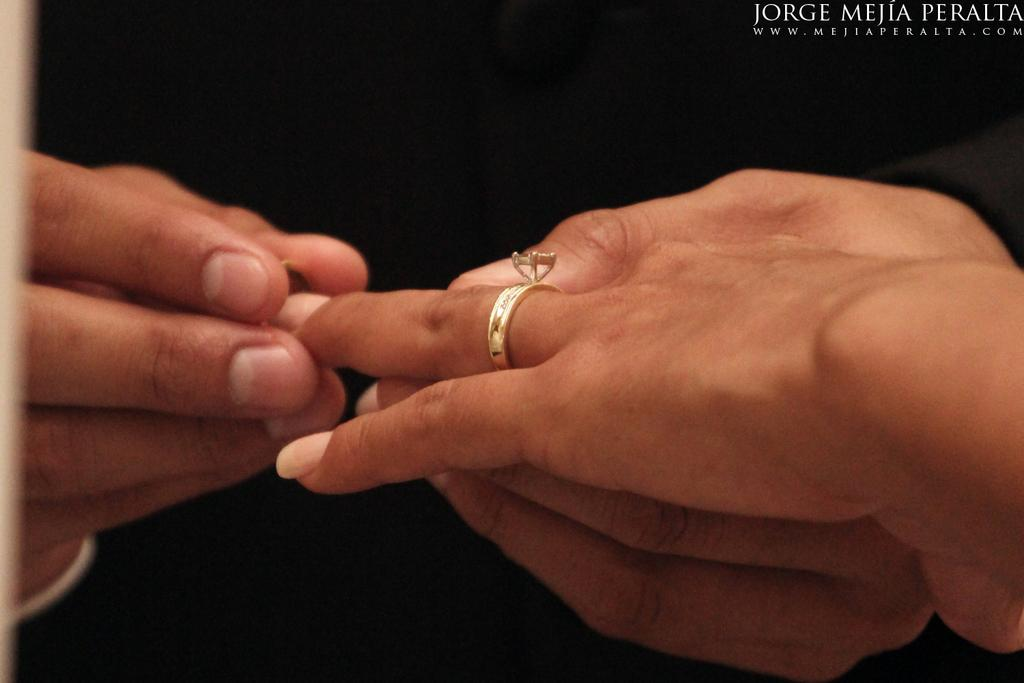What is the main focus of the image? The main focus of the image is human hands. What objects can be seen on the hands? There are two rings on the hands. Is there any additional information or markings in the image? Yes, there is a watermark on the top right of the image. How many baby roots are visible in the image? There are no baby roots present in the image; it features human hands with rings and a watermark. 